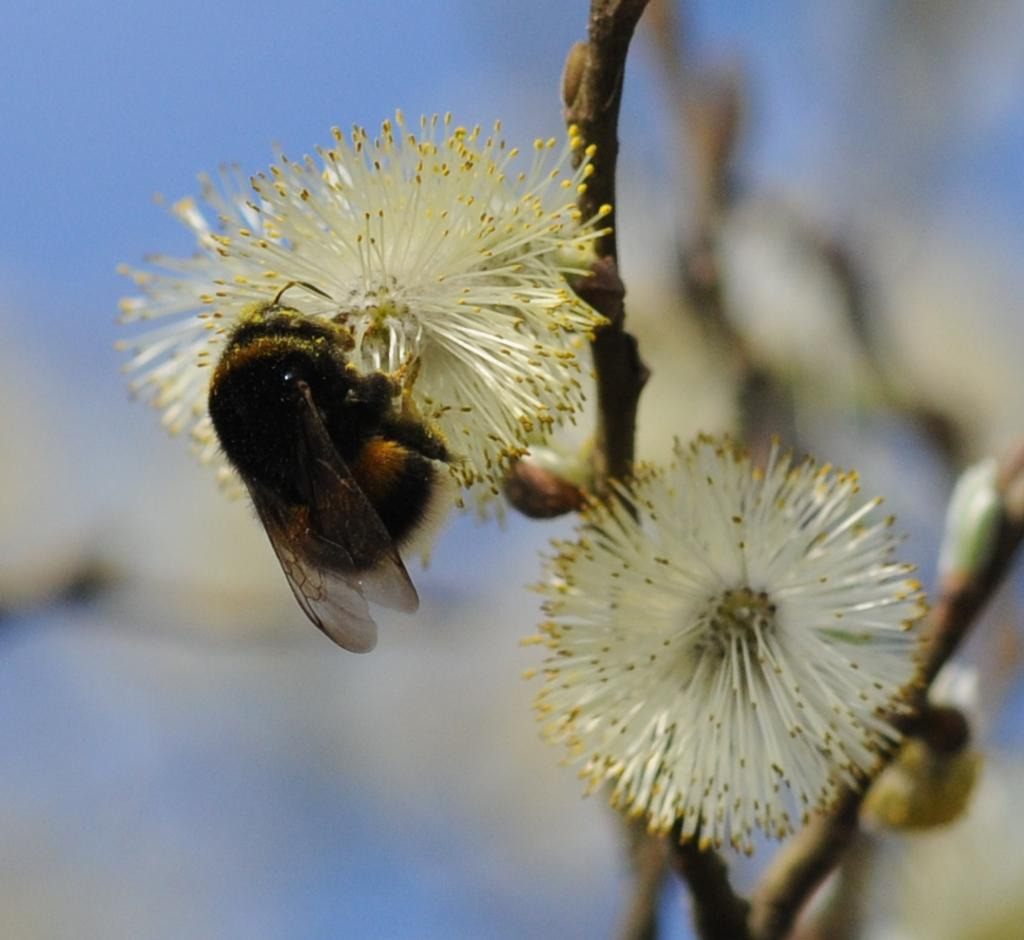What is on the flower in the image? There is an insect on a flower in the image. Can you describe the other flower in the image? There is another flower in the foreground of the image. What type of health advice can be seen on the flower in the image? There is no health advice present on the flower in the image; it features an insect and another flower. What type of home does the insect live in on the flower in the image? There is no indication of a home for the insect on the flower in the image. 